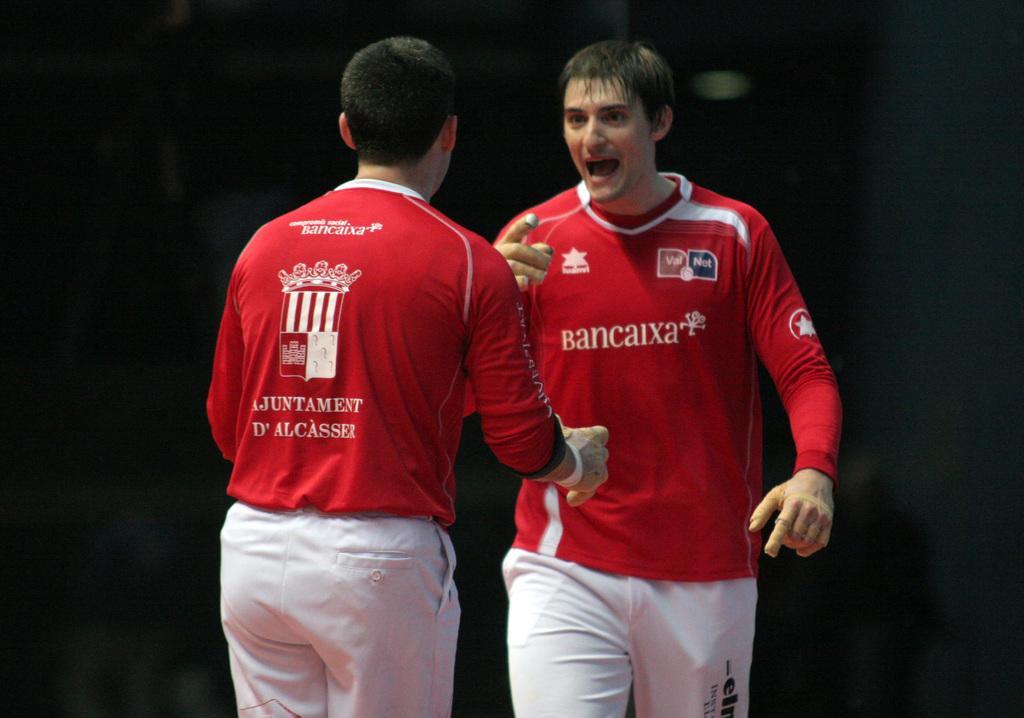Can you describe this image briefly? In this picture I can see 2 men in front who are wearing same color dresses and I see something is written on their t-shirts and I can also see logos. I see that it is dark in the background. 